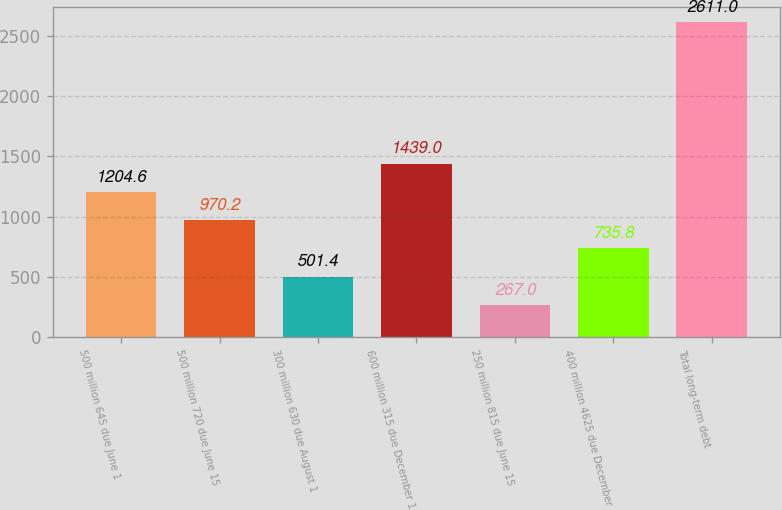Convert chart. <chart><loc_0><loc_0><loc_500><loc_500><bar_chart><fcel>500 million 645 due June 1<fcel>500 million 720 due June 15<fcel>300 million 630 due August 1<fcel>600 million 315 due December 1<fcel>250 million 815 due June 15<fcel>400 million 4625 due December<fcel>Total long-term debt<nl><fcel>1204.6<fcel>970.2<fcel>501.4<fcel>1439<fcel>267<fcel>735.8<fcel>2611<nl></chart> 